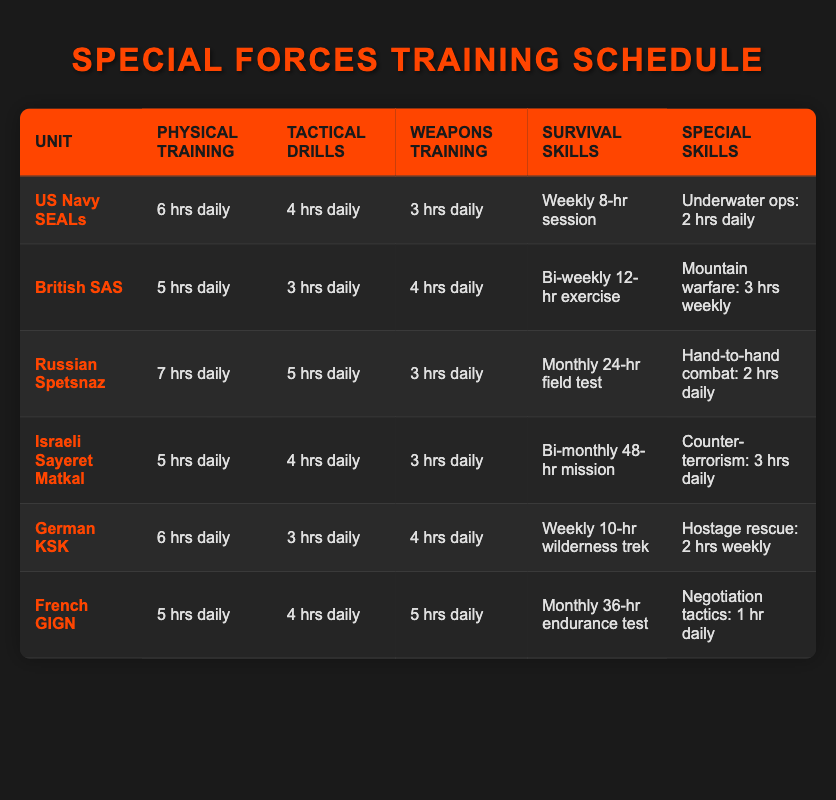What is the daily physical training duration for the Russian Spetsnaz? The table shows that the Russian Spetsnaz have a daily physical training duration of 7 hours. This information is explicitly listed under the "Physical Training" column for that specific unit.
Answer: 7 hrs daily Which unit conducts bi-weekly survival skill exercises? Under the "Survival Skills" column, the British SAS is noted to conduct bi-weekly 12-hour exercises. This straightforward retrieval of information is directly visible in the table.
Answer: British SAS What is the total weekly hours spent on special skills training for the US Navy SEALs? The US Navy SEALs dedicate 2 hours daily to special skills training. To find the weekly total, we multiply 2 hours by 7 days, resulting in 14 hours for the week.
Answer: 14 hrs weekly Does the German KSK have more hours allocated to weapons training than the French GIGN? The German KSK has 4 hours of weapons training daily while the French GIGN has 5 hours. Comparing these values, the GIGN indeed has more hours allocated. Thus, the statement is true.
Answer: Yes What is the average daily physical training hours across all units? To find the average, we first sum the physical training hours: 6 (SEALs) + 5 (SAS) + 7 (Spetsnaz) + 5 (Sayeret) + 6 (KSK) + 5 (GIGN) = 34 total hours. Considering there are 6 units, we divide this sum by 6, giving us an average of 5.67 hours daily.
Answer: 5.67 hrs daily Which unit spends the least amount of time on tactical drills? The British SAS spends 3 hours daily on tactical drills, which is the least compared to other units listed. The information is taken directly from the "Tactical Drills" column.
Answer: British SAS How often does the Israeli Sayeret Matkal conduct their survival skills training? The Israeli Sayeret Matkal conducts bi-monthly 48-hour missions for survival skills training. This frequency is specified in the "Survival Skills" column for this unit.
Answer: Bi-monthly Which unit has the most extensive physical training schedule? The Russian Spetsnaz has the highest daily physical training duration listed at 7 hours. This can be determined by reviewing the "Physical Training" column to identify which value is the greatest.
Answer: Russian Spetsnaz What type of special skills training do the French GIGN focus on? The French GIGN specialize in negotiation tactics, allocating 1 hour daily for this specific training. This detail is provided in the "Special Skills" column of the respective row.
Answer: Negotiation tactics 